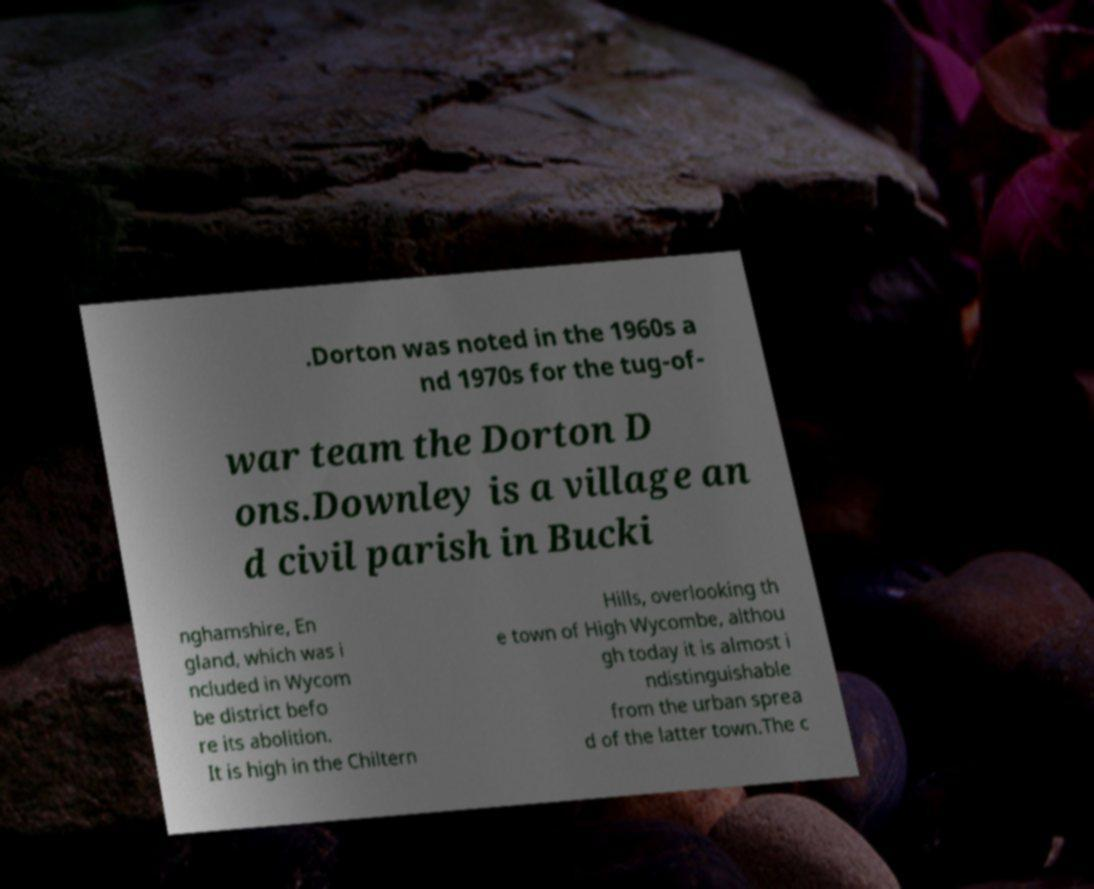Please read and relay the text visible in this image. What does it say? .Dorton was noted in the 1960s a nd 1970s for the tug-of- war team the Dorton D ons.Downley is a village an d civil parish in Bucki nghamshire, En gland, which was i ncluded in Wycom be district befo re its abolition. It is high in the Chiltern Hills, overlooking th e town of High Wycombe, althou gh today it is almost i ndistinguishable from the urban sprea d of the latter town.The c 